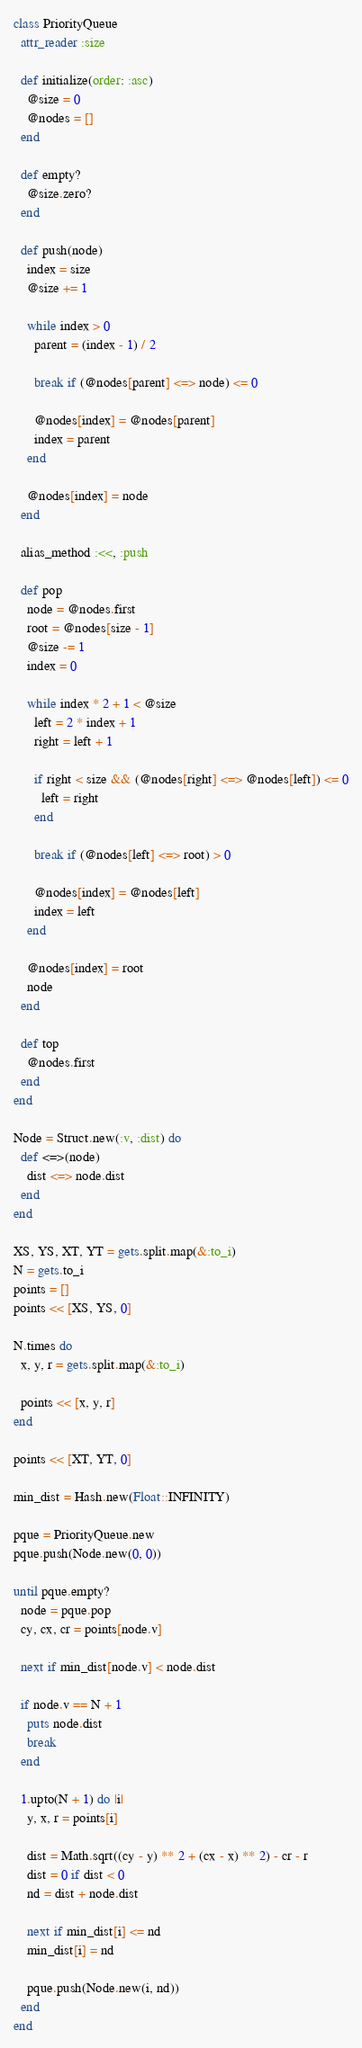<code> <loc_0><loc_0><loc_500><loc_500><_Ruby_>class PriorityQueue
  attr_reader :size

  def initialize(order: :asc)
    @size = 0
    @nodes = []
  end

  def empty?
    @size.zero?
  end

  def push(node)
    index = size
    @size += 1

    while index > 0
      parent = (index - 1) / 2

      break if (@nodes[parent] <=> node) <= 0

      @nodes[index] = @nodes[parent]
      index = parent
    end

    @nodes[index] = node
  end

  alias_method :<<, :push

  def pop
    node = @nodes.first
    root = @nodes[size - 1]
    @size -= 1
    index = 0

    while index * 2 + 1 < @size
      left = 2 * index + 1
      right = left + 1

      if right < size && (@nodes[right] <=> @nodes[left]) <= 0
        left = right
      end

      break if (@nodes[left] <=> root) > 0

      @nodes[index] = @nodes[left]
      index = left
    end

    @nodes[index] = root
    node
  end

  def top
    @nodes.first
  end
end

Node = Struct.new(:v, :dist) do
  def <=>(node)
    dist <=> node.dist
  end
end

XS, YS, XT, YT = gets.split.map(&:to_i)
N = gets.to_i
points = []
points << [XS, YS, 0]

N.times do
  x, y, r = gets.split.map(&:to_i)

  points << [x, y, r]
end

points << [XT, YT, 0]

min_dist = Hash.new(Float::INFINITY)

pque = PriorityQueue.new
pque.push(Node.new(0, 0))

until pque.empty?
  node = pque.pop
  cy, cx, cr = points[node.v]

  next if min_dist[node.v] < node.dist

  if node.v == N + 1
    puts node.dist
    break
  end

  1.upto(N + 1) do |i|
    y, x, r = points[i]

    dist = Math.sqrt((cy - y) ** 2 + (cx - x) ** 2) - cr - r
    dist = 0 if dist < 0
    nd = dist + node.dist

    next if min_dist[i] <= nd
    min_dist[i] = nd

    pque.push(Node.new(i, nd))
  end
end
</code> 